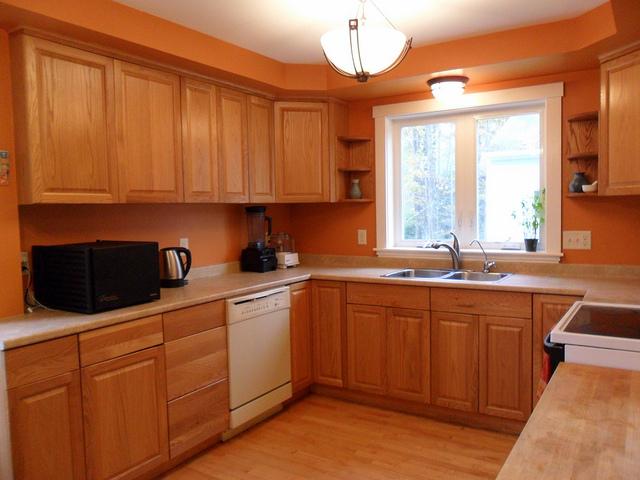What kind of light is in the kitchen?
Concise answer only. Overhead. Is this kitchen refurbished?
Give a very brief answer. Yes. What are the cabinets made out of?
Be succinct. Wood. 